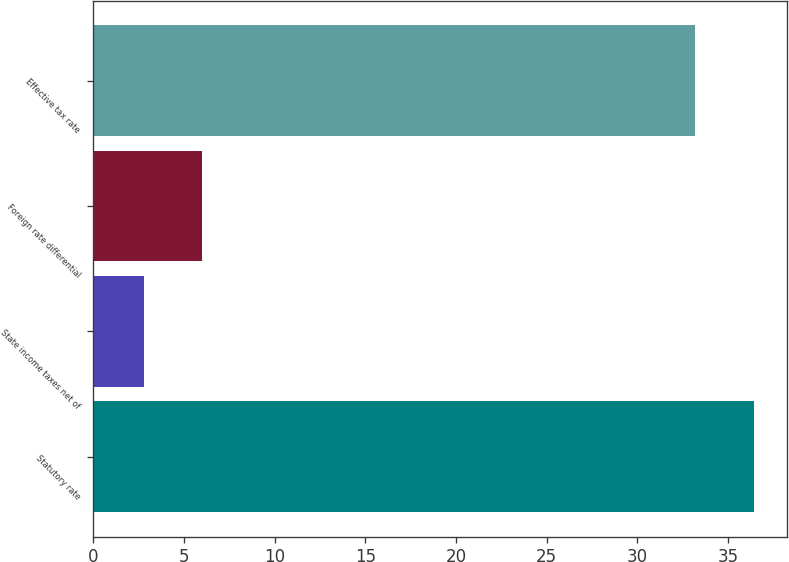Convert chart. <chart><loc_0><loc_0><loc_500><loc_500><bar_chart><fcel>Statutory rate<fcel>State income taxes net of<fcel>Foreign rate differential<fcel>Effective tax rate<nl><fcel>36.42<fcel>2.8<fcel>6.02<fcel>33.2<nl></chart> 